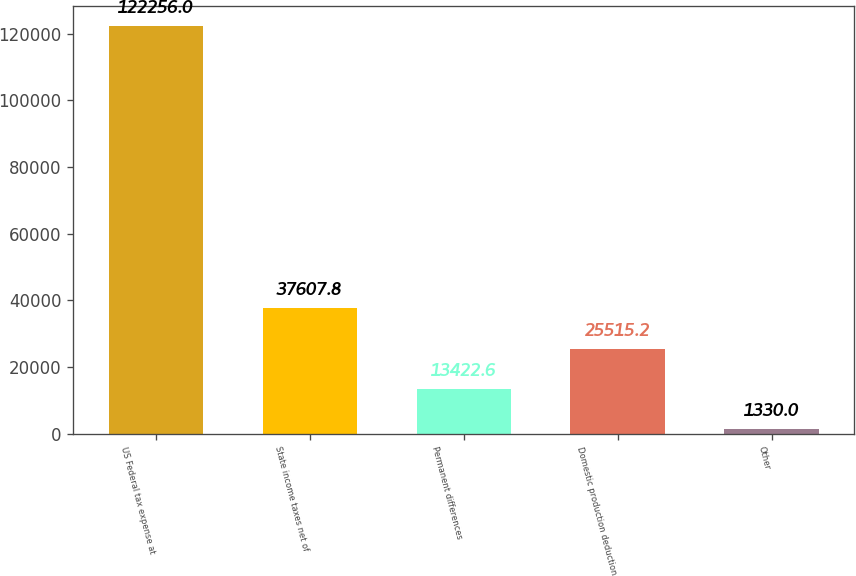<chart> <loc_0><loc_0><loc_500><loc_500><bar_chart><fcel>US Federal tax expense at<fcel>State income taxes net of<fcel>Permanent differences<fcel>Domestic production deduction<fcel>Other<nl><fcel>122256<fcel>37607.8<fcel>13422.6<fcel>25515.2<fcel>1330<nl></chart> 